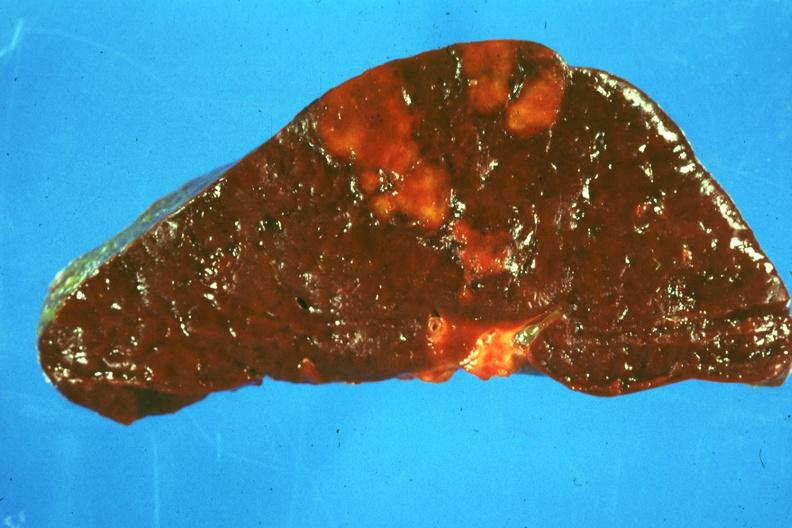what is present?
Answer the question using a single word or phrase. Spleen 